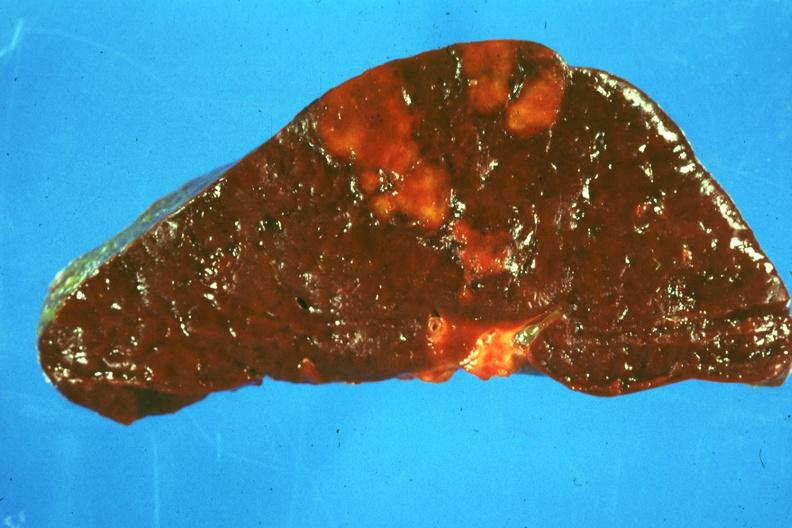what is present?
Answer the question using a single word or phrase. Spleen 